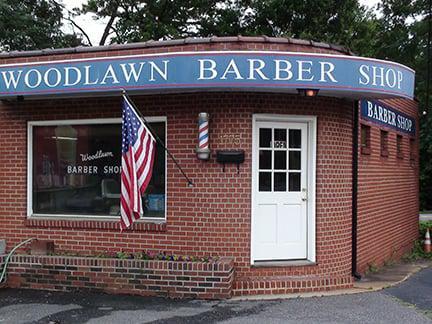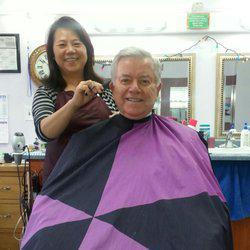The first image is the image on the left, the second image is the image on the right. Considering the images on both sides, is "One image is the outside of a barber shop and the other image is the inside of a barber shop." valid? Answer yes or no. Yes. The first image is the image on the left, the second image is the image on the right. Examine the images to the left and right. Is the description "A woman is cutting a male's hair in at least one of the images." accurate? Answer yes or no. Yes. 